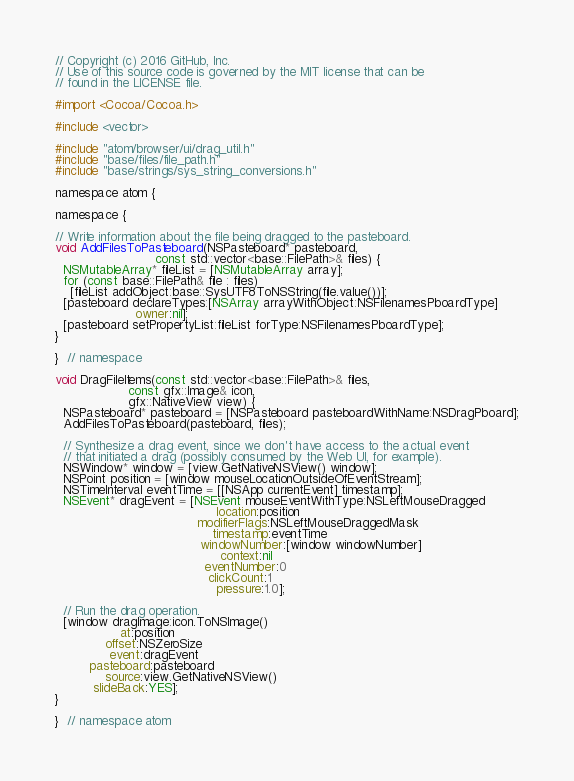Convert code to text. <code><loc_0><loc_0><loc_500><loc_500><_ObjectiveC_>// Copyright (c) 2016 GitHub, Inc.
// Use of this source code is governed by the MIT license that can be
// found in the LICENSE file.

#import <Cocoa/Cocoa.h>

#include <vector>

#include "atom/browser/ui/drag_util.h"
#include "base/files/file_path.h"
#include "base/strings/sys_string_conversions.h"

namespace atom {

namespace {

// Write information about the file being dragged to the pasteboard.
void AddFilesToPasteboard(NSPasteboard* pasteboard,
                          const std::vector<base::FilePath>& files) {
  NSMutableArray* fileList = [NSMutableArray array];
  for (const base::FilePath& file : files)
    [fileList addObject:base::SysUTF8ToNSString(file.value())];
  [pasteboard declareTypes:[NSArray arrayWithObject:NSFilenamesPboardType]
                     owner:nil];
  [pasteboard setPropertyList:fileList forType:NSFilenamesPboardType];
}

}  // namespace

void DragFileItems(const std::vector<base::FilePath>& files,
                   const gfx::Image& icon,
                   gfx::NativeView view) {
  NSPasteboard* pasteboard = [NSPasteboard pasteboardWithName:NSDragPboard];
  AddFilesToPasteboard(pasteboard, files);

  // Synthesize a drag event, since we don't have access to the actual event
  // that initiated a drag (possibly consumed by the Web UI, for example).
  NSWindow* window = [view.GetNativeNSView() window];
  NSPoint position = [window mouseLocationOutsideOfEventStream];
  NSTimeInterval eventTime = [[NSApp currentEvent] timestamp];
  NSEvent* dragEvent = [NSEvent mouseEventWithType:NSLeftMouseDragged
                                          location:position
                                     modifierFlags:NSLeftMouseDraggedMask
                                         timestamp:eventTime
                                      windowNumber:[window windowNumber]
                                           context:nil
                                       eventNumber:0
                                        clickCount:1
                                          pressure:1.0];

  // Run the drag operation.
  [window dragImage:icon.ToNSImage()
                 at:position
             offset:NSZeroSize
              event:dragEvent
         pasteboard:pasteboard
             source:view.GetNativeNSView()
          slideBack:YES];
}

}  // namespace atom
</code> 